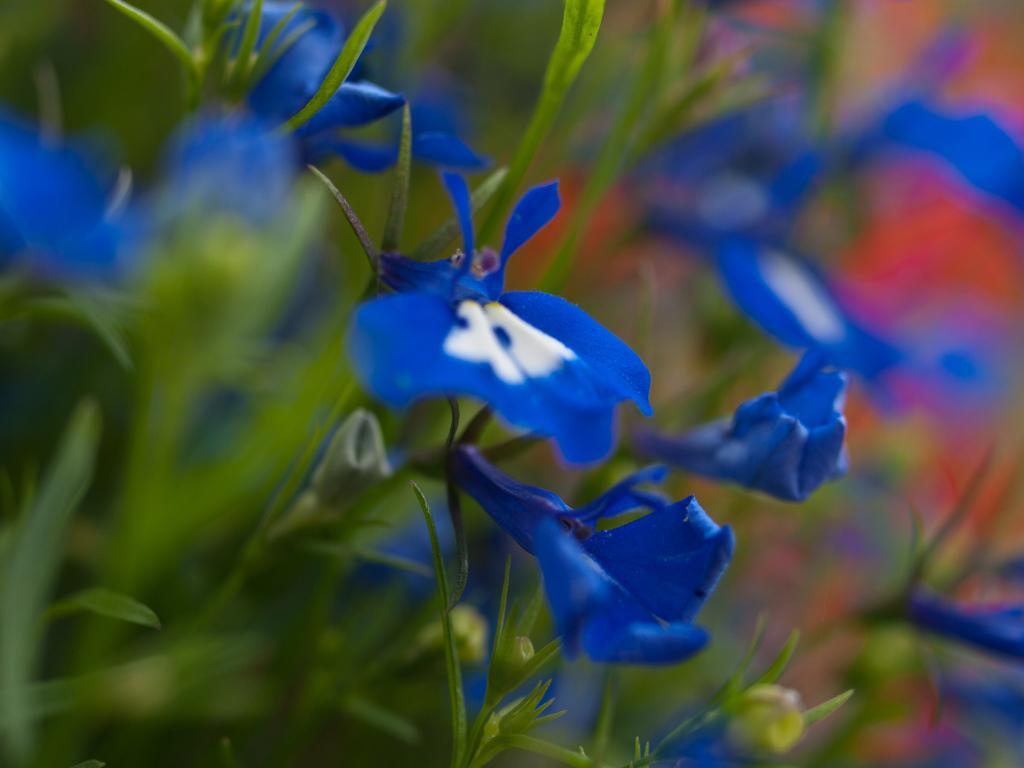Could you give a brief overview of what you see in this image? There are plants which have blue flowers. 